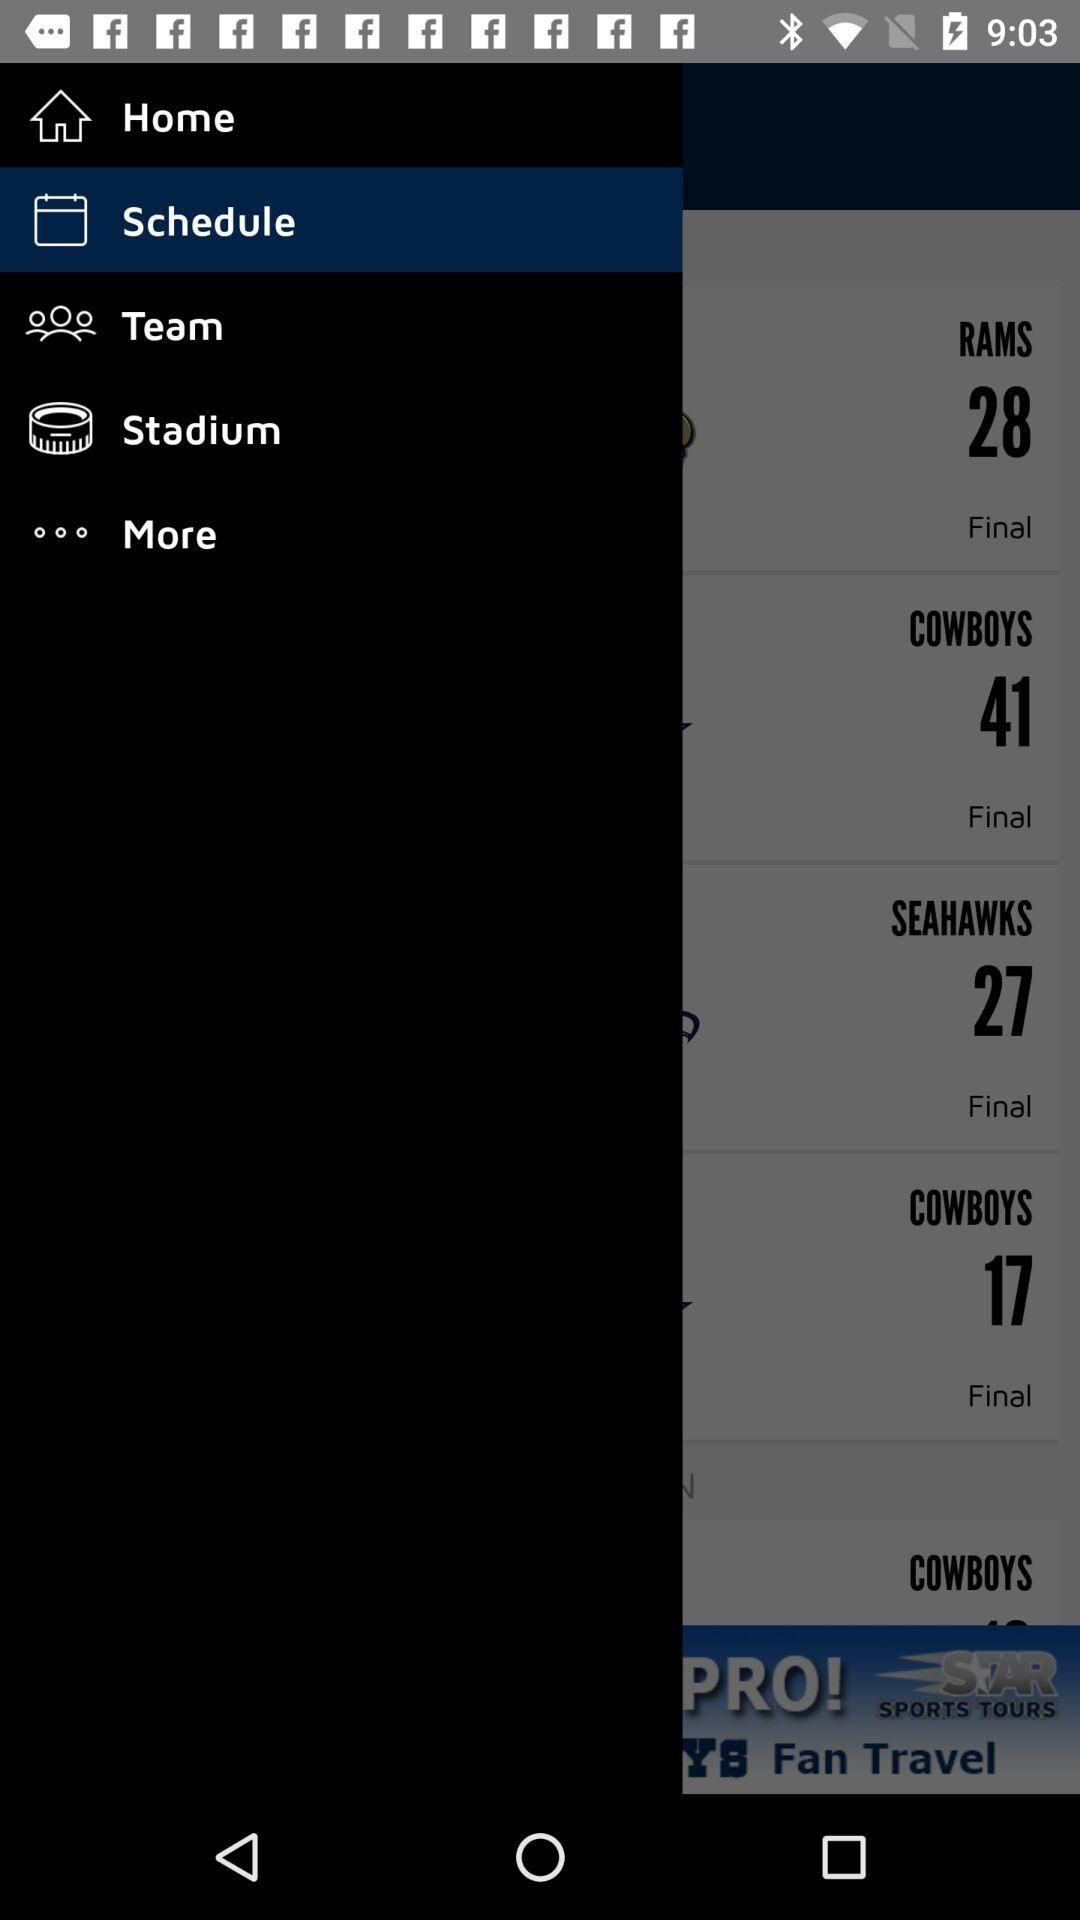How many more points did the Cowboys score than the Rams?
Answer the question using a single word or phrase. 13 